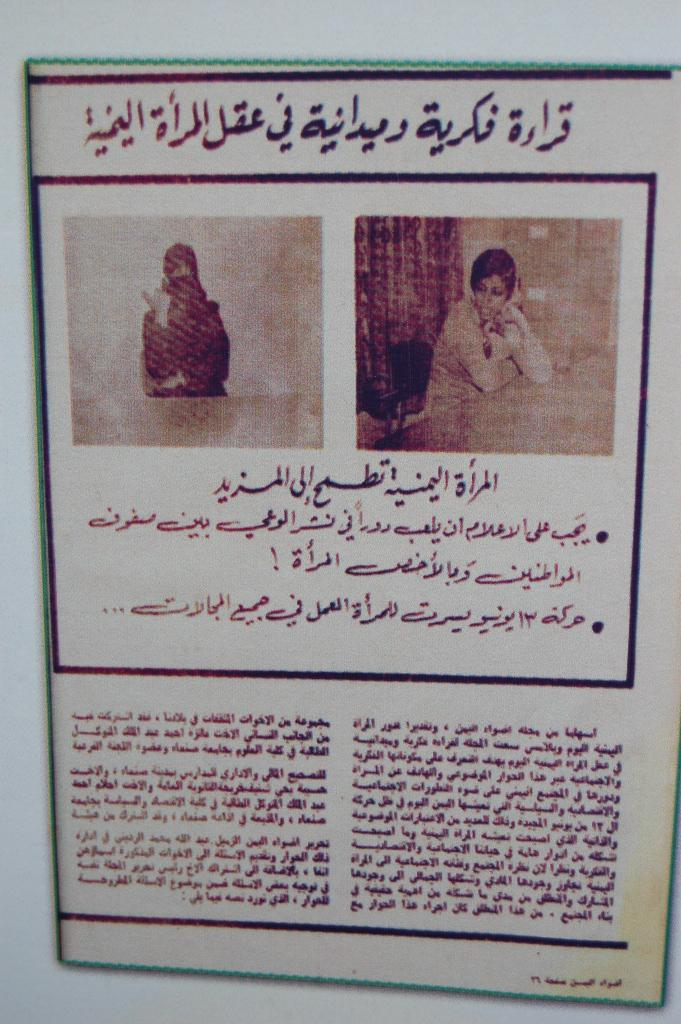What is the main object in the image? There is a paper in the image. What can be seen on the paper? The paper contains images of people. What is the person in the image doing? The person is sitting in a chair in front of a table in the image. What else is visible on the paper besides the images of people? Text is visible in the image. What type of plant is growing on the table in the image? There is no plant visible on the table in the image. What event is taking place in the image? The image does not depict a specific event; it shows a person sitting in front of a table with a paper. 